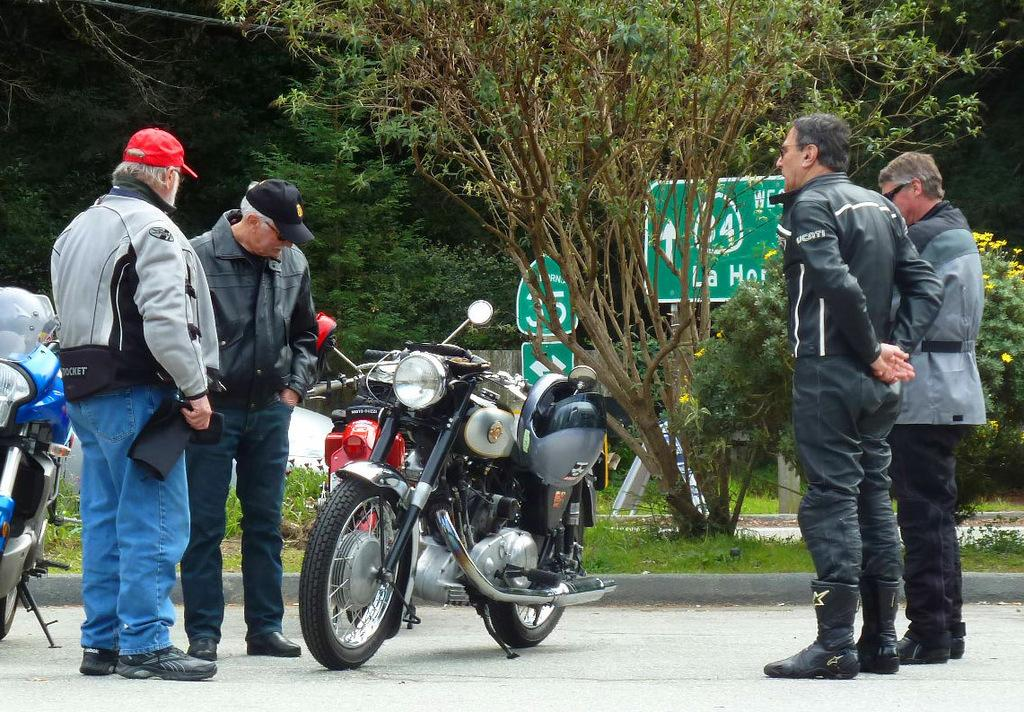What type of vehicles are in the image? There are bikes in the image. What are the people in the image doing? The people are standing on the road in the image. What type of vegetation is visible in the image? There are plants and trees visible in the image. What is attached to the pole in the image? There are boards on a pole in the image. Can you see any army personnel or vehicles in the image? No, there is no army personnel or vehicles present in the image. Is there a frog or fowl visible in the image? No, there is no frog or fowl present in the image. 